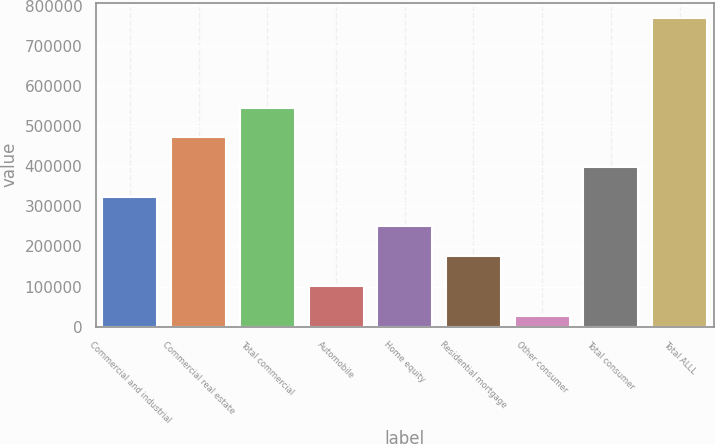<chart> <loc_0><loc_0><loc_500><loc_500><bar_chart><fcel>Commercial and industrial<fcel>Commercial real estate<fcel>Total commercial<fcel>Automobile<fcel>Home equity<fcel>Residential mortgage<fcel>Other consumer<fcel>Total consumer<fcel>Total ALLL<nl><fcel>323982<fcel>472347<fcel>546529<fcel>101436<fcel>249800<fcel>175618<fcel>27254<fcel>398164<fcel>769075<nl></chart> 